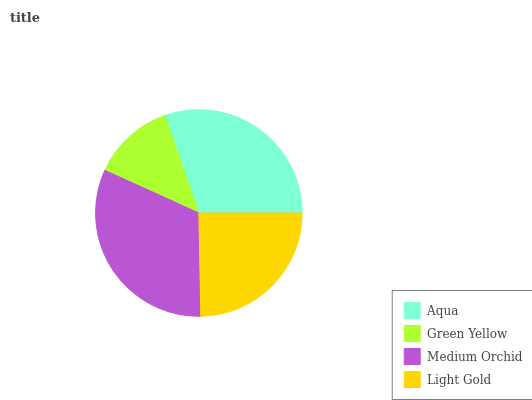Is Green Yellow the minimum?
Answer yes or no. Yes. Is Medium Orchid the maximum?
Answer yes or no. Yes. Is Medium Orchid the minimum?
Answer yes or no. No. Is Green Yellow the maximum?
Answer yes or no. No. Is Medium Orchid greater than Green Yellow?
Answer yes or no. Yes. Is Green Yellow less than Medium Orchid?
Answer yes or no. Yes. Is Green Yellow greater than Medium Orchid?
Answer yes or no. No. Is Medium Orchid less than Green Yellow?
Answer yes or no. No. Is Aqua the high median?
Answer yes or no. Yes. Is Light Gold the low median?
Answer yes or no. Yes. Is Green Yellow the high median?
Answer yes or no. No. Is Medium Orchid the low median?
Answer yes or no. No. 